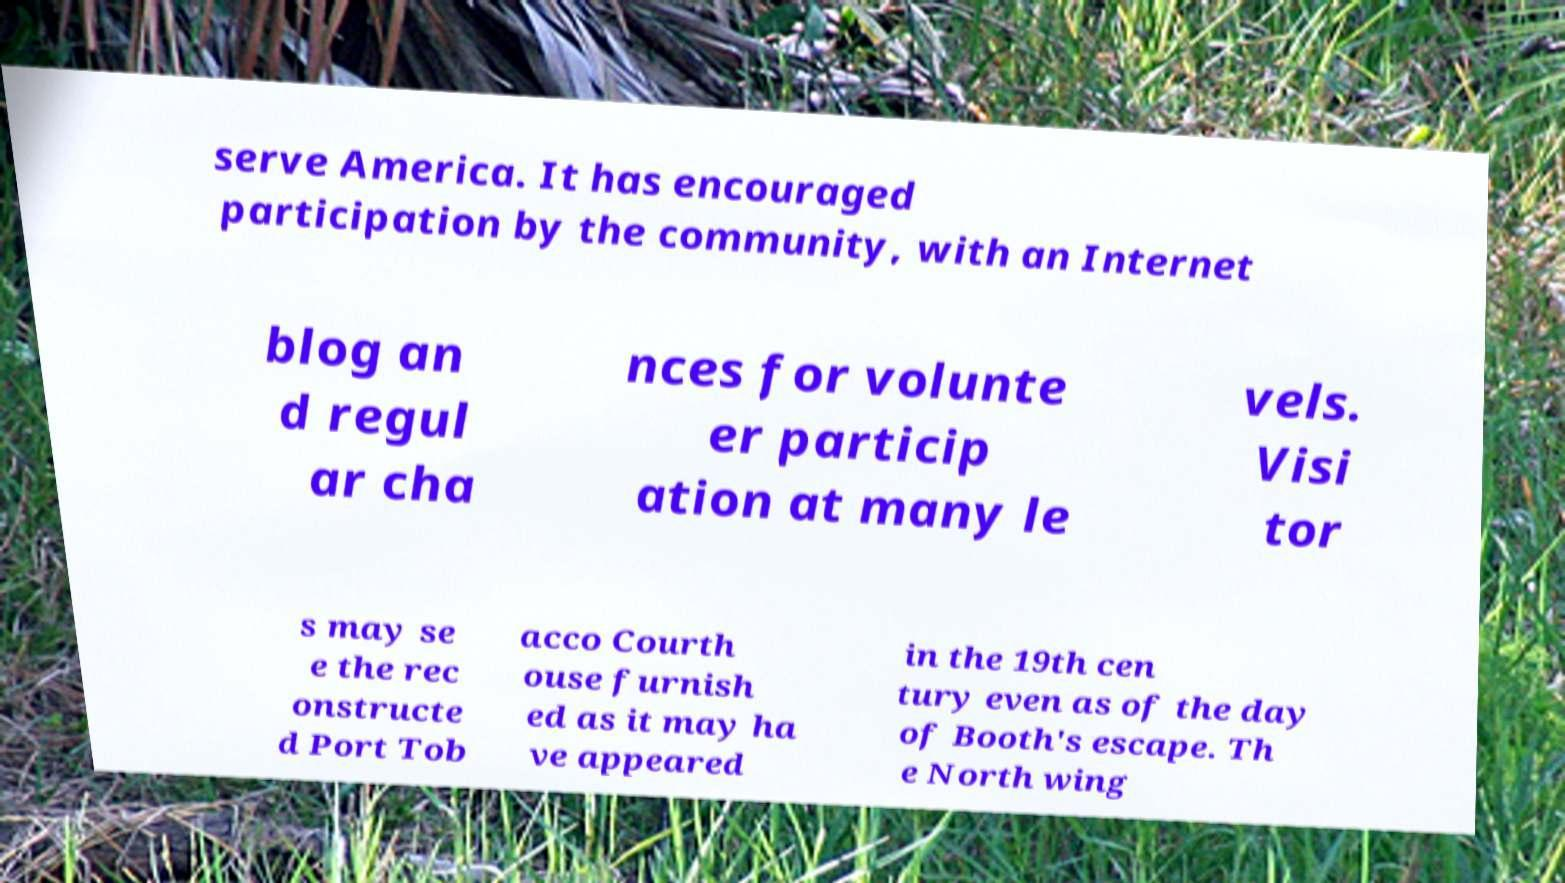Can you accurately transcribe the text from the provided image for me? serve America. It has encouraged participation by the community, with an Internet blog an d regul ar cha nces for volunte er particip ation at many le vels. Visi tor s may se e the rec onstructe d Port Tob acco Courth ouse furnish ed as it may ha ve appeared in the 19th cen tury even as of the day of Booth's escape. Th e North wing 